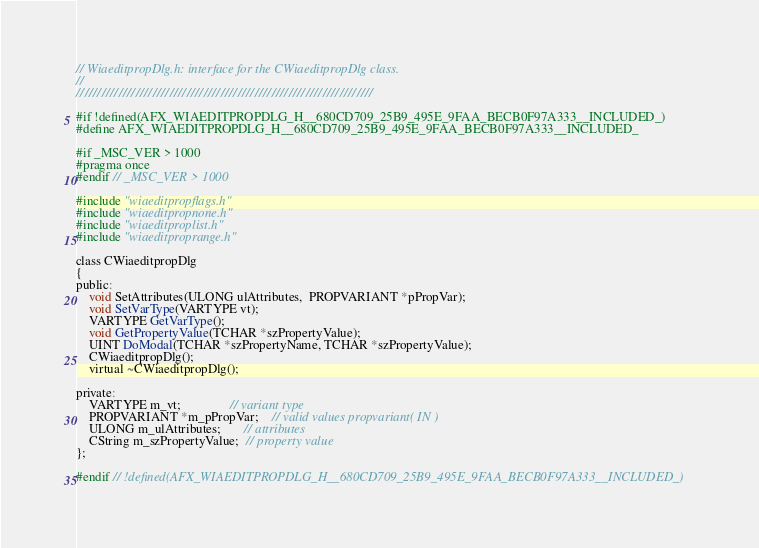Convert code to text. <code><loc_0><loc_0><loc_500><loc_500><_C_>// WiaeditpropDlg.h: interface for the CWiaeditpropDlg class.
//
//////////////////////////////////////////////////////////////////////

#if !defined(AFX_WIAEDITPROPDLG_H__680CD709_25B9_495E_9FAA_BECB0F97A333__INCLUDED_)
#define AFX_WIAEDITPROPDLG_H__680CD709_25B9_495E_9FAA_BECB0F97A333__INCLUDED_

#if _MSC_VER > 1000
#pragma once
#endif // _MSC_VER > 1000

#include "wiaeditpropflags.h"
#include "wiaeditpropnone.h"
#include "wiaeditproplist.h"
#include "wiaeditproprange.h"

class CWiaeditpropDlg  
{
public:	
	void SetAttributes(ULONG ulAttributes,  PROPVARIANT *pPropVar);
    void SetVarType(VARTYPE vt);
    VARTYPE GetVarType();
    void GetPropertyValue(TCHAR *szPropertyValue);
	UINT DoModal(TCHAR *szPropertyName, TCHAR *szPropertyValue);
	CWiaeditpropDlg();
	virtual ~CWiaeditpropDlg();

private:
    VARTYPE m_vt;               // variant type
	PROPVARIANT *m_pPropVar;    // valid values propvariant( IN )
    ULONG m_ulAttributes;       // attributes
    CString m_szPropertyValue;  // property value
};

#endif // !defined(AFX_WIAEDITPROPDLG_H__680CD709_25B9_495E_9FAA_BECB0F97A333__INCLUDED_)
</code> 